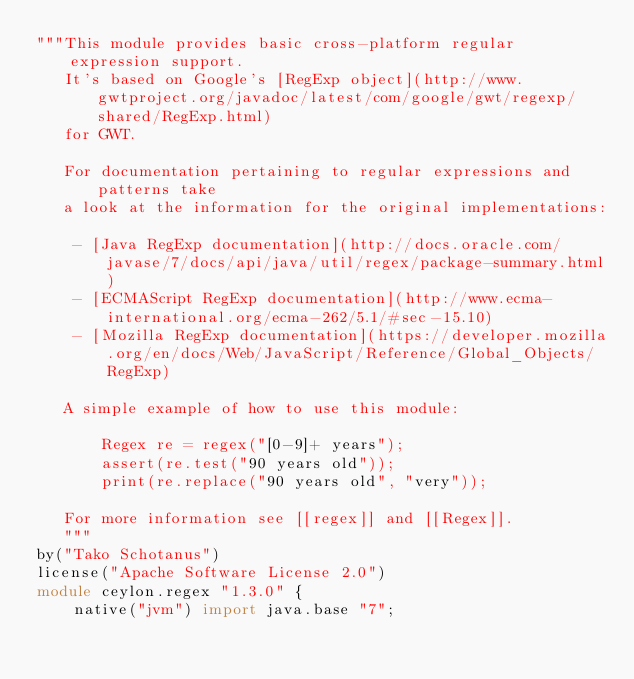<code> <loc_0><loc_0><loc_500><loc_500><_Ceylon_>"""This module provides basic cross-platform regular expression support.
   It's based on Google's [RegExp object](http://www.gwtproject.org/javadoc/latest/com/google/gwt/regexp/shared/RegExp.html)
   for GWT.
   
   For documentation pertaining to regular expressions and patterns take
   a look at the information for the original implementations:
   
    - [Java RegExp documentation](http://docs.oracle.com/javase/7/docs/api/java/util/regex/package-summary.html)
    - [ECMAScript RegExp documentation](http://www.ecma-international.org/ecma-262/5.1/#sec-15.10)
    - [Mozilla RegExp documentation](https://developer.mozilla.org/en/docs/Web/JavaScript/Reference/Global_Objects/RegExp)
   
   A simple example of how to use this module:
   
       Regex re = regex("[0-9]+ years");
       assert(re.test("90 years old"));
       print(re.replace("90 years old", "very"));

   For more information see [[regex]] and [[Regex]].
   """
by("Tako Schotanus")
license("Apache Software License 2.0")
module ceylon.regex "1.3.0" {
    native("jvm") import java.base "7";</code> 